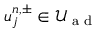Convert formula to latex. <formula><loc_0><loc_0><loc_500><loc_500>u _ { j } ^ { n , \pm } \in \mathcal { U } _ { a d }</formula> 